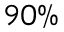<formula> <loc_0><loc_0><loc_500><loc_500>9 0 \%</formula> 